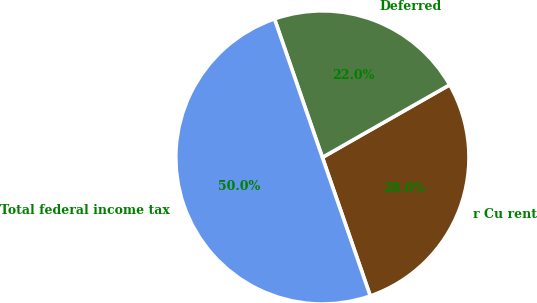<chart> <loc_0><loc_0><loc_500><loc_500><pie_chart><fcel>r Cu rent<fcel>Deferred<fcel>Total federal income tax<nl><fcel>27.95%<fcel>22.05%<fcel>50.0%<nl></chart> 